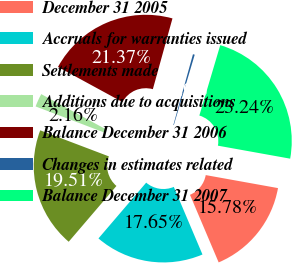<chart> <loc_0><loc_0><loc_500><loc_500><pie_chart><fcel>December 31 2005<fcel>Accruals for warranties issued<fcel>Settlements made<fcel>Additions due to acquisitions<fcel>Balance December 31 2006<fcel>Changes in estimates related<fcel>Balance December 31 2007<nl><fcel>15.78%<fcel>17.65%<fcel>19.51%<fcel>2.16%<fcel>21.37%<fcel>0.29%<fcel>23.24%<nl></chart> 